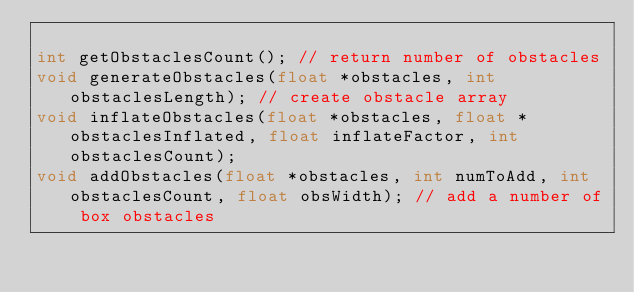Convert code to text. <code><loc_0><loc_0><loc_500><loc_500><_Cuda_>
int getObstaclesCount(); // return number of obstacles
void generateObstacles(float *obstacles, int obstaclesLength); // create obstacle array
void inflateObstacles(float *obstacles, float *obstaclesInflated, float inflateFactor, int obstaclesCount);
void addObstacles(float *obstacles, int numToAdd, int obstaclesCount, float obsWidth); // add a number of box obstacles </code> 